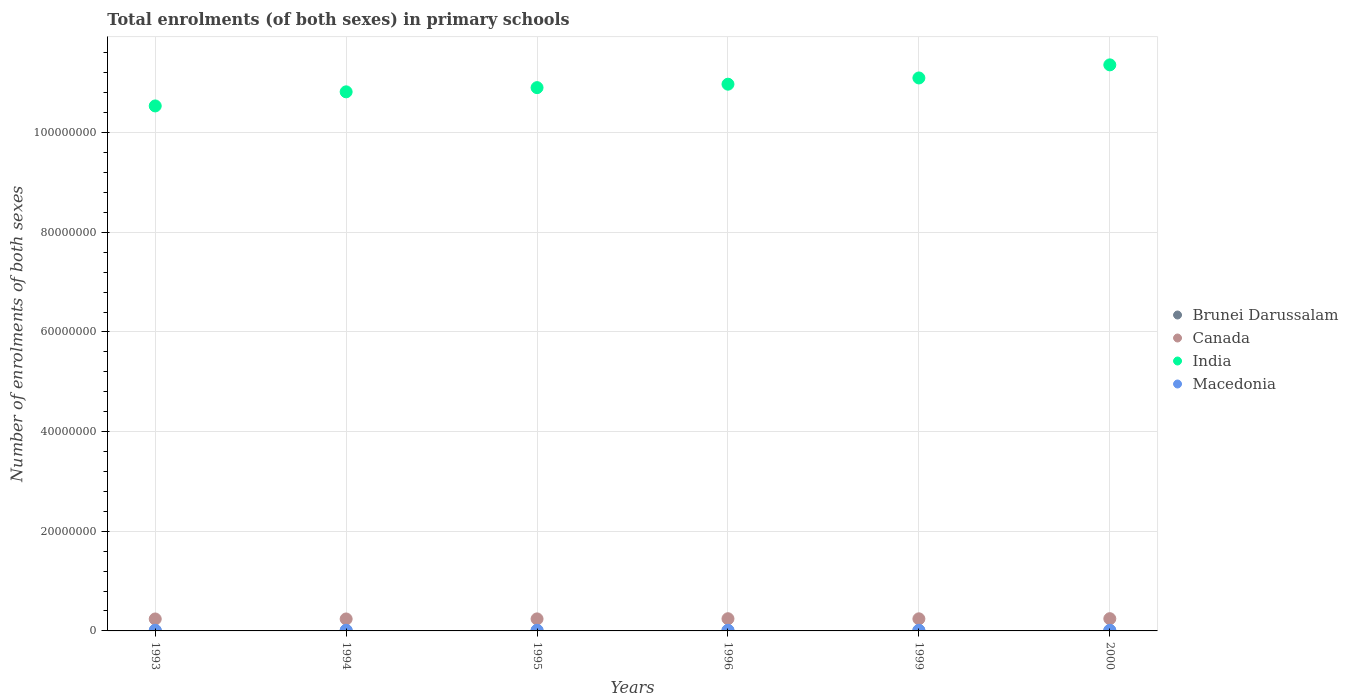How many different coloured dotlines are there?
Make the answer very short. 4. Is the number of dotlines equal to the number of legend labels?
Keep it short and to the point. Yes. What is the number of enrolments in primary schools in Macedonia in 1993?
Keep it short and to the point. 1.34e+05. Across all years, what is the maximum number of enrolments in primary schools in India?
Provide a succinct answer. 1.14e+08. Across all years, what is the minimum number of enrolments in primary schools in Canada?
Provide a succinct answer. 2.40e+06. In which year was the number of enrolments in primary schools in India maximum?
Provide a short and direct response. 2000. What is the total number of enrolments in primary schools in Canada in the graph?
Offer a terse response. 1.45e+07. What is the difference between the number of enrolments in primary schools in India in 1995 and that in 2000?
Provide a succinct answer. -4.57e+06. What is the difference between the number of enrolments in primary schools in Canada in 1999 and the number of enrolments in primary schools in Macedonia in 2000?
Offer a very short reply. 2.30e+06. What is the average number of enrolments in primary schools in Canada per year?
Your response must be concise. 2.42e+06. In the year 1995, what is the difference between the number of enrolments in primary schools in India and number of enrolments in primary schools in Brunei Darussalam?
Make the answer very short. 1.09e+08. In how many years, is the number of enrolments in primary schools in Brunei Darussalam greater than 12000000?
Your response must be concise. 0. What is the ratio of the number of enrolments in primary schools in Brunei Darussalam in 1995 to that in 2000?
Provide a succinct answer. 0.94. Is the difference between the number of enrolments in primary schools in India in 1994 and 2000 greater than the difference between the number of enrolments in primary schools in Brunei Darussalam in 1994 and 2000?
Make the answer very short. No. What is the difference between the highest and the second highest number of enrolments in primary schools in India?
Offer a terse response. 2.63e+06. What is the difference between the highest and the lowest number of enrolments in primary schools in Macedonia?
Keep it short and to the point. 7991. In how many years, is the number of enrolments in primary schools in Brunei Darussalam greater than the average number of enrolments in primary schools in Brunei Darussalam taken over all years?
Offer a very short reply. 2. Is the sum of the number of enrolments in primary schools in Canada in 1993 and 1996 greater than the maximum number of enrolments in primary schools in India across all years?
Your answer should be very brief. No. Is it the case that in every year, the sum of the number of enrolments in primary schools in India and number of enrolments in primary schools in Macedonia  is greater than the sum of number of enrolments in primary schools in Brunei Darussalam and number of enrolments in primary schools in Canada?
Provide a succinct answer. Yes. Is the number of enrolments in primary schools in India strictly greater than the number of enrolments in primary schools in Canada over the years?
Your response must be concise. Yes. Is the number of enrolments in primary schools in Brunei Darussalam strictly less than the number of enrolments in primary schools in Macedonia over the years?
Make the answer very short. Yes. How many dotlines are there?
Ensure brevity in your answer.  4. How many years are there in the graph?
Make the answer very short. 6. What is the difference between two consecutive major ticks on the Y-axis?
Provide a short and direct response. 2.00e+07. Are the values on the major ticks of Y-axis written in scientific E-notation?
Your answer should be compact. No. Does the graph contain any zero values?
Provide a succinct answer. No. How many legend labels are there?
Give a very brief answer. 4. What is the title of the graph?
Your response must be concise. Total enrolments (of both sexes) in primary schools. What is the label or title of the Y-axis?
Offer a terse response. Number of enrolments of both sexes. What is the Number of enrolments of both sexes of Brunei Darussalam in 1993?
Your answer should be compact. 4.11e+04. What is the Number of enrolments of both sexes in Canada in 1993?
Offer a terse response. 2.40e+06. What is the Number of enrolments of both sexes in India in 1993?
Your response must be concise. 1.05e+08. What is the Number of enrolments of both sexes in Macedonia in 1993?
Your response must be concise. 1.34e+05. What is the Number of enrolments of both sexes in Brunei Darussalam in 1994?
Offer a terse response. 4.23e+04. What is the Number of enrolments of both sexes in Canada in 1994?
Offer a very short reply. 2.40e+06. What is the Number of enrolments of both sexes of India in 1994?
Provide a short and direct response. 1.08e+08. What is the Number of enrolments of both sexes in Macedonia in 1994?
Provide a succinct answer. 1.34e+05. What is the Number of enrolments of both sexes of Brunei Darussalam in 1995?
Your answer should be very brief. 4.27e+04. What is the Number of enrolments of both sexes in Canada in 1995?
Your answer should be very brief. 2.41e+06. What is the Number of enrolments of both sexes in India in 1995?
Your answer should be compact. 1.09e+08. What is the Number of enrolments of both sexes in Macedonia in 1995?
Your answer should be compact. 1.34e+05. What is the Number of enrolments of both sexes in Brunei Darussalam in 1996?
Give a very brief answer. 4.33e+04. What is the Number of enrolments of both sexes in Canada in 1996?
Your answer should be very brief. 2.45e+06. What is the Number of enrolments of both sexes of India in 1996?
Ensure brevity in your answer.  1.10e+08. What is the Number of enrolments of both sexes in Macedonia in 1996?
Offer a very short reply. 1.35e+05. What is the Number of enrolments of both sexes of Brunei Darussalam in 1999?
Your answer should be very brief. 4.58e+04. What is the Number of enrolments of both sexes of Canada in 1999?
Your answer should be very brief. 2.43e+06. What is the Number of enrolments of both sexes in India in 1999?
Give a very brief answer. 1.11e+08. What is the Number of enrolments of both sexes of Macedonia in 1999?
Keep it short and to the point. 1.30e+05. What is the Number of enrolments of both sexes of Brunei Darussalam in 2000?
Your answer should be very brief. 4.54e+04. What is the Number of enrolments of both sexes of Canada in 2000?
Offer a very short reply. 2.46e+06. What is the Number of enrolments of both sexes in India in 2000?
Ensure brevity in your answer.  1.14e+08. What is the Number of enrolments of both sexes of Macedonia in 2000?
Provide a succinct answer. 1.27e+05. Across all years, what is the maximum Number of enrolments of both sexes in Brunei Darussalam?
Provide a succinct answer. 4.58e+04. Across all years, what is the maximum Number of enrolments of both sexes in Canada?
Provide a succinct answer. 2.46e+06. Across all years, what is the maximum Number of enrolments of both sexes of India?
Offer a terse response. 1.14e+08. Across all years, what is the maximum Number of enrolments of both sexes in Macedonia?
Keep it short and to the point. 1.35e+05. Across all years, what is the minimum Number of enrolments of both sexes of Brunei Darussalam?
Your response must be concise. 4.11e+04. Across all years, what is the minimum Number of enrolments of both sexes in Canada?
Your answer should be very brief. 2.40e+06. Across all years, what is the minimum Number of enrolments of both sexes of India?
Ensure brevity in your answer.  1.05e+08. Across all years, what is the minimum Number of enrolments of both sexes of Macedonia?
Offer a terse response. 1.27e+05. What is the total Number of enrolments of both sexes in Brunei Darussalam in the graph?
Provide a succinct answer. 2.61e+05. What is the total Number of enrolments of both sexes in Canada in the graph?
Offer a terse response. 1.45e+07. What is the total Number of enrolments of both sexes in India in the graph?
Your response must be concise. 6.57e+08. What is the total Number of enrolments of both sexes in Macedonia in the graph?
Provide a short and direct response. 7.93e+05. What is the difference between the Number of enrolments of both sexes of Brunei Darussalam in 1993 and that in 1994?
Keep it short and to the point. -1136. What is the difference between the Number of enrolments of both sexes of Canada in 1993 and that in 1994?
Ensure brevity in your answer.  -1595. What is the difference between the Number of enrolments of both sexes of India in 1993 and that in 1994?
Provide a succinct answer. -2.83e+06. What is the difference between the Number of enrolments of both sexes of Macedonia in 1993 and that in 1994?
Offer a very short reply. 516. What is the difference between the Number of enrolments of both sexes of Brunei Darussalam in 1993 and that in 1995?
Your answer should be very brief. -1538. What is the difference between the Number of enrolments of both sexes of Canada in 1993 and that in 1995?
Your response must be concise. -1.39e+04. What is the difference between the Number of enrolments of both sexes in India in 1993 and that in 1995?
Keep it short and to the point. -3.67e+06. What is the difference between the Number of enrolments of both sexes of Macedonia in 1993 and that in 1995?
Provide a succinct answer. 553. What is the difference between the Number of enrolments of both sexes in Brunei Darussalam in 1993 and that in 1996?
Ensure brevity in your answer.  -2157. What is the difference between the Number of enrolments of both sexes in Canada in 1993 and that in 1996?
Your answer should be very brief. -4.89e+04. What is the difference between the Number of enrolments of both sexes in India in 1993 and that in 1996?
Offer a very short reply. -4.36e+06. What is the difference between the Number of enrolments of both sexes in Macedonia in 1993 and that in 1996?
Your answer should be very brief. -337. What is the difference between the Number of enrolments of both sexes of Brunei Darussalam in 1993 and that in 1999?
Your answer should be very brief. -4693. What is the difference between the Number of enrolments of both sexes in Canada in 1993 and that in 1999?
Provide a short and direct response. -2.94e+04. What is the difference between the Number of enrolments of both sexes in India in 1993 and that in 1999?
Your answer should be very brief. -5.62e+06. What is the difference between the Number of enrolments of both sexes in Macedonia in 1993 and that in 1999?
Offer a very short reply. 4627. What is the difference between the Number of enrolments of both sexes in Brunei Darussalam in 1993 and that in 2000?
Keep it short and to the point. -4294. What is the difference between the Number of enrolments of both sexes in Canada in 1993 and that in 2000?
Your answer should be compact. -5.72e+04. What is the difference between the Number of enrolments of both sexes of India in 1993 and that in 2000?
Ensure brevity in your answer.  -8.24e+06. What is the difference between the Number of enrolments of both sexes of Macedonia in 1993 and that in 2000?
Offer a very short reply. 7654. What is the difference between the Number of enrolments of both sexes of Brunei Darussalam in 1994 and that in 1995?
Your answer should be very brief. -402. What is the difference between the Number of enrolments of both sexes in Canada in 1994 and that in 1995?
Keep it short and to the point. -1.23e+04. What is the difference between the Number of enrolments of both sexes in India in 1994 and that in 1995?
Provide a succinct answer. -8.43e+05. What is the difference between the Number of enrolments of both sexes in Brunei Darussalam in 1994 and that in 1996?
Your answer should be compact. -1021. What is the difference between the Number of enrolments of both sexes of Canada in 1994 and that in 1996?
Provide a succinct answer. -4.73e+04. What is the difference between the Number of enrolments of both sexes in India in 1994 and that in 1996?
Give a very brief answer. -1.53e+06. What is the difference between the Number of enrolments of both sexes in Macedonia in 1994 and that in 1996?
Provide a short and direct response. -853. What is the difference between the Number of enrolments of both sexes of Brunei Darussalam in 1994 and that in 1999?
Make the answer very short. -3557. What is the difference between the Number of enrolments of both sexes of Canada in 1994 and that in 1999?
Give a very brief answer. -2.78e+04. What is the difference between the Number of enrolments of both sexes of India in 1994 and that in 1999?
Offer a very short reply. -2.79e+06. What is the difference between the Number of enrolments of both sexes of Macedonia in 1994 and that in 1999?
Make the answer very short. 4111. What is the difference between the Number of enrolments of both sexes in Brunei Darussalam in 1994 and that in 2000?
Provide a short and direct response. -3158. What is the difference between the Number of enrolments of both sexes in Canada in 1994 and that in 2000?
Provide a short and direct response. -5.56e+04. What is the difference between the Number of enrolments of both sexes of India in 1994 and that in 2000?
Your response must be concise. -5.41e+06. What is the difference between the Number of enrolments of both sexes in Macedonia in 1994 and that in 2000?
Keep it short and to the point. 7138. What is the difference between the Number of enrolments of both sexes of Brunei Darussalam in 1995 and that in 1996?
Provide a succinct answer. -619. What is the difference between the Number of enrolments of both sexes in Canada in 1995 and that in 1996?
Provide a succinct answer. -3.50e+04. What is the difference between the Number of enrolments of both sexes in India in 1995 and that in 1996?
Offer a very short reply. -6.91e+05. What is the difference between the Number of enrolments of both sexes of Macedonia in 1995 and that in 1996?
Your answer should be very brief. -890. What is the difference between the Number of enrolments of both sexes in Brunei Darussalam in 1995 and that in 1999?
Your response must be concise. -3155. What is the difference between the Number of enrolments of both sexes in Canada in 1995 and that in 1999?
Give a very brief answer. -1.55e+04. What is the difference between the Number of enrolments of both sexes of India in 1995 and that in 1999?
Your answer should be very brief. -1.94e+06. What is the difference between the Number of enrolments of both sexes of Macedonia in 1995 and that in 1999?
Give a very brief answer. 4074. What is the difference between the Number of enrolments of both sexes in Brunei Darussalam in 1995 and that in 2000?
Give a very brief answer. -2756. What is the difference between the Number of enrolments of both sexes in Canada in 1995 and that in 2000?
Offer a terse response. -4.33e+04. What is the difference between the Number of enrolments of both sexes of India in 1995 and that in 2000?
Your response must be concise. -4.57e+06. What is the difference between the Number of enrolments of both sexes of Macedonia in 1995 and that in 2000?
Make the answer very short. 7101. What is the difference between the Number of enrolments of both sexes of Brunei Darussalam in 1996 and that in 1999?
Ensure brevity in your answer.  -2536. What is the difference between the Number of enrolments of both sexes of Canada in 1996 and that in 1999?
Your response must be concise. 1.95e+04. What is the difference between the Number of enrolments of both sexes of India in 1996 and that in 1999?
Provide a short and direct response. -1.25e+06. What is the difference between the Number of enrolments of both sexes in Macedonia in 1996 and that in 1999?
Your answer should be compact. 4964. What is the difference between the Number of enrolments of both sexes in Brunei Darussalam in 1996 and that in 2000?
Keep it short and to the point. -2137. What is the difference between the Number of enrolments of both sexes in Canada in 1996 and that in 2000?
Make the answer very short. -8290. What is the difference between the Number of enrolments of both sexes of India in 1996 and that in 2000?
Your response must be concise. -3.88e+06. What is the difference between the Number of enrolments of both sexes of Macedonia in 1996 and that in 2000?
Make the answer very short. 7991. What is the difference between the Number of enrolments of both sexes of Brunei Darussalam in 1999 and that in 2000?
Offer a terse response. 399. What is the difference between the Number of enrolments of both sexes in Canada in 1999 and that in 2000?
Keep it short and to the point. -2.78e+04. What is the difference between the Number of enrolments of both sexes in India in 1999 and that in 2000?
Offer a very short reply. -2.63e+06. What is the difference between the Number of enrolments of both sexes in Macedonia in 1999 and that in 2000?
Provide a succinct answer. 3027. What is the difference between the Number of enrolments of both sexes of Brunei Darussalam in 1993 and the Number of enrolments of both sexes of Canada in 1994?
Offer a terse response. -2.36e+06. What is the difference between the Number of enrolments of both sexes of Brunei Darussalam in 1993 and the Number of enrolments of both sexes of India in 1994?
Offer a very short reply. -1.08e+08. What is the difference between the Number of enrolments of both sexes in Brunei Darussalam in 1993 and the Number of enrolments of both sexes in Macedonia in 1994?
Make the answer very short. -9.26e+04. What is the difference between the Number of enrolments of both sexes in Canada in 1993 and the Number of enrolments of both sexes in India in 1994?
Offer a terse response. -1.06e+08. What is the difference between the Number of enrolments of both sexes of Canada in 1993 and the Number of enrolments of both sexes of Macedonia in 1994?
Your answer should be very brief. 2.27e+06. What is the difference between the Number of enrolments of both sexes of India in 1993 and the Number of enrolments of both sexes of Macedonia in 1994?
Keep it short and to the point. 1.05e+08. What is the difference between the Number of enrolments of both sexes of Brunei Darussalam in 1993 and the Number of enrolments of both sexes of Canada in 1995?
Give a very brief answer. -2.37e+06. What is the difference between the Number of enrolments of both sexes in Brunei Darussalam in 1993 and the Number of enrolments of both sexes in India in 1995?
Offer a terse response. -1.09e+08. What is the difference between the Number of enrolments of both sexes in Brunei Darussalam in 1993 and the Number of enrolments of both sexes in Macedonia in 1995?
Give a very brief answer. -9.26e+04. What is the difference between the Number of enrolments of both sexes in Canada in 1993 and the Number of enrolments of both sexes in India in 1995?
Your answer should be very brief. -1.07e+08. What is the difference between the Number of enrolments of both sexes in Canada in 1993 and the Number of enrolments of both sexes in Macedonia in 1995?
Offer a terse response. 2.27e+06. What is the difference between the Number of enrolments of both sexes in India in 1993 and the Number of enrolments of both sexes in Macedonia in 1995?
Your answer should be compact. 1.05e+08. What is the difference between the Number of enrolments of both sexes in Brunei Darussalam in 1993 and the Number of enrolments of both sexes in Canada in 1996?
Offer a very short reply. -2.41e+06. What is the difference between the Number of enrolments of both sexes of Brunei Darussalam in 1993 and the Number of enrolments of both sexes of India in 1996?
Ensure brevity in your answer.  -1.10e+08. What is the difference between the Number of enrolments of both sexes in Brunei Darussalam in 1993 and the Number of enrolments of both sexes in Macedonia in 1996?
Provide a succinct answer. -9.35e+04. What is the difference between the Number of enrolments of both sexes in Canada in 1993 and the Number of enrolments of both sexes in India in 1996?
Ensure brevity in your answer.  -1.07e+08. What is the difference between the Number of enrolments of both sexes of Canada in 1993 and the Number of enrolments of both sexes of Macedonia in 1996?
Offer a very short reply. 2.26e+06. What is the difference between the Number of enrolments of both sexes of India in 1993 and the Number of enrolments of both sexes of Macedonia in 1996?
Offer a very short reply. 1.05e+08. What is the difference between the Number of enrolments of both sexes of Brunei Darussalam in 1993 and the Number of enrolments of both sexes of Canada in 1999?
Your answer should be very brief. -2.39e+06. What is the difference between the Number of enrolments of both sexes in Brunei Darussalam in 1993 and the Number of enrolments of both sexes in India in 1999?
Your answer should be compact. -1.11e+08. What is the difference between the Number of enrolments of both sexes of Brunei Darussalam in 1993 and the Number of enrolments of both sexes of Macedonia in 1999?
Provide a succinct answer. -8.85e+04. What is the difference between the Number of enrolments of both sexes of Canada in 1993 and the Number of enrolments of both sexes of India in 1999?
Your response must be concise. -1.09e+08. What is the difference between the Number of enrolments of both sexes in Canada in 1993 and the Number of enrolments of both sexes in Macedonia in 1999?
Your answer should be very brief. 2.27e+06. What is the difference between the Number of enrolments of both sexes of India in 1993 and the Number of enrolments of both sexes of Macedonia in 1999?
Provide a short and direct response. 1.05e+08. What is the difference between the Number of enrolments of both sexes of Brunei Darussalam in 1993 and the Number of enrolments of both sexes of Canada in 2000?
Your response must be concise. -2.42e+06. What is the difference between the Number of enrolments of both sexes in Brunei Darussalam in 1993 and the Number of enrolments of both sexes in India in 2000?
Offer a terse response. -1.14e+08. What is the difference between the Number of enrolments of both sexes in Brunei Darussalam in 1993 and the Number of enrolments of both sexes in Macedonia in 2000?
Provide a succinct answer. -8.55e+04. What is the difference between the Number of enrolments of both sexes of Canada in 1993 and the Number of enrolments of both sexes of India in 2000?
Give a very brief answer. -1.11e+08. What is the difference between the Number of enrolments of both sexes in Canada in 1993 and the Number of enrolments of both sexes in Macedonia in 2000?
Offer a terse response. 2.27e+06. What is the difference between the Number of enrolments of both sexes in India in 1993 and the Number of enrolments of both sexes in Macedonia in 2000?
Your answer should be very brief. 1.05e+08. What is the difference between the Number of enrolments of both sexes of Brunei Darussalam in 1994 and the Number of enrolments of both sexes of Canada in 1995?
Your response must be concise. -2.37e+06. What is the difference between the Number of enrolments of both sexes in Brunei Darussalam in 1994 and the Number of enrolments of both sexes in India in 1995?
Ensure brevity in your answer.  -1.09e+08. What is the difference between the Number of enrolments of both sexes in Brunei Darussalam in 1994 and the Number of enrolments of both sexes in Macedonia in 1995?
Keep it short and to the point. -9.14e+04. What is the difference between the Number of enrolments of both sexes of Canada in 1994 and the Number of enrolments of both sexes of India in 1995?
Make the answer very short. -1.07e+08. What is the difference between the Number of enrolments of both sexes in Canada in 1994 and the Number of enrolments of both sexes in Macedonia in 1995?
Keep it short and to the point. 2.27e+06. What is the difference between the Number of enrolments of both sexes in India in 1994 and the Number of enrolments of both sexes in Macedonia in 1995?
Offer a terse response. 1.08e+08. What is the difference between the Number of enrolments of both sexes in Brunei Darussalam in 1994 and the Number of enrolments of both sexes in Canada in 1996?
Your answer should be compact. -2.41e+06. What is the difference between the Number of enrolments of both sexes of Brunei Darussalam in 1994 and the Number of enrolments of both sexes of India in 1996?
Provide a short and direct response. -1.10e+08. What is the difference between the Number of enrolments of both sexes in Brunei Darussalam in 1994 and the Number of enrolments of both sexes in Macedonia in 1996?
Your answer should be compact. -9.23e+04. What is the difference between the Number of enrolments of both sexes of Canada in 1994 and the Number of enrolments of both sexes of India in 1996?
Provide a short and direct response. -1.07e+08. What is the difference between the Number of enrolments of both sexes of Canada in 1994 and the Number of enrolments of both sexes of Macedonia in 1996?
Offer a terse response. 2.27e+06. What is the difference between the Number of enrolments of both sexes of India in 1994 and the Number of enrolments of both sexes of Macedonia in 1996?
Your answer should be very brief. 1.08e+08. What is the difference between the Number of enrolments of both sexes of Brunei Darussalam in 1994 and the Number of enrolments of both sexes of Canada in 1999?
Make the answer very short. -2.39e+06. What is the difference between the Number of enrolments of both sexes of Brunei Darussalam in 1994 and the Number of enrolments of both sexes of India in 1999?
Your answer should be very brief. -1.11e+08. What is the difference between the Number of enrolments of both sexes in Brunei Darussalam in 1994 and the Number of enrolments of both sexes in Macedonia in 1999?
Give a very brief answer. -8.74e+04. What is the difference between the Number of enrolments of both sexes of Canada in 1994 and the Number of enrolments of both sexes of India in 1999?
Your answer should be very brief. -1.09e+08. What is the difference between the Number of enrolments of both sexes in Canada in 1994 and the Number of enrolments of both sexes in Macedonia in 1999?
Offer a very short reply. 2.27e+06. What is the difference between the Number of enrolments of both sexes of India in 1994 and the Number of enrolments of both sexes of Macedonia in 1999?
Your response must be concise. 1.08e+08. What is the difference between the Number of enrolments of both sexes of Brunei Darussalam in 1994 and the Number of enrolments of both sexes of Canada in 2000?
Offer a very short reply. -2.41e+06. What is the difference between the Number of enrolments of both sexes of Brunei Darussalam in 1994 and the Number of enrolments of both sexes of India in 2000?
Provide a succinct answer. -1.14e+08. What is the difference between the Number of enrolments of both sexes in Brunei Darussalam in 1994 and the Number of enrolments of both sexes in Macedonia in 2000?
Give a very brief answer. -8.43e+04. What is the difference between the Number of enrolments of both sexes of Canada in 1994 and the Number of enrolments of both sexes of India in 2000?
Keep it short and to the point. -1.11e+08. What is the difference between the Number of enrolments of both sexes of Canada in 1994 and the Number of enrolments of both sexes of Macedonia in 2000?
Offer a very short reply. 2.27e+06. What is the difference between the Number of enrolments of both sexes of India in 1994 and the Number of enrolments of both sexes of Macedonia in 2000?
Offer a terse response. 1.08e+08. What is the difference between the Number of enrolments of both sexes in Brunei Darussalam in 1995 and the Number of enrolments of both sexes in Canada in 1996?
Your answer should be very brief. -2.41e+06. What is the difference between the Number of enrolments of both sexes in Brunei Darussalam in 1995 and the Number of enrolments of both sexes in India in 1996?
Offer a terse response. -1.10e+08. What is the difference between the Number of enrolments of both sexes in Brunei Darussalam in 1995 and the Number of enrolments of both sexes in Macedonia in 1996?
Give a very brief answer. -9.19e+04. What is the difference between the Number of enrolments of both sexes in Canada in 1995 and the Number of enrolments of both sexes in India in 1996?
Your response must be concise. -1.07e+08. What is the difference between the Number of enrolments of both sexes of Canada in 1995 and the Number of enrolments of both sexes of Macedonia in 1996?
Make the answer very short. 2.28e+06. What is the difference between the Number of enrolments of both sexes in India in 1995 and the Number of enrolments of both sexes in Macedonia in 1996?
Your answer should be very brief. 1.09e+08. What is the difference between the Number of enrolments of both sexes of Brunei Darussalam in 1995 and the Number of enrolments of both sexes of Canada in 1999?
Your answer should be compact. -2.39e+06. What is the difference between the Number of enrolments of both sexes of Brunei Darussalam in 1995 and the Number of enrolments of both sexes of India in 1999?
Offer a very short reply. -1.11e+08. What is the difference between the Number of enrolments of both sexes in Brunei Darussalam in 1995 and the Number of enrolments of both sexes in Macedonia in 1999?
Make the answer very short. -8.70e+04. What is the difference between the Number of enrolments of both sexes of Canada in 1995 and the Number of enrolments of both sexes of India in 1999?
Provide a succinct answer. -1.09e+08. What is the difference between the Number of enrolments of both sexes of Canada in 1995 and the Number of enrolments of both sexes of Macedonia in 1999?
Offer a terse response. 2.28e+06. What is the difference between the Number of enrolments of both sexes of India in 1995 and the Number of enrolments of both sexes of Macedonia in 1999?
Provide a short and direct response. 1.09e+08. What is the difference between the Number of enrolments of both sexes in Brunei Darussalam in 1995 and the Number of enrolments of both sexes in Canada in 2000?
Ensure brevity in your answer.  -2.41e+06. What is the difference between the Number of enrolments of both sexes in Brunei Darussalam in 1995 and the Number of enrolments of both sexes in India in 2000?
Your answer should be very brief. -1.14e+08. What is the difference between the Number of enrolments of both sexes of Brunei Darussalam in 1995 and the Number of enrolments of both sexes of Macedonia in 2000?
Provide a succinct answer. -8.39e+04. What is the difference between the Number of enrolments of both sexes in Canada in 1995 and the Number of enrolments of both sexes in India in 2000?
Ensure brevity in your answer.  -1.11e+08. What is the difference between the Number of enrolments of both sexes of Canada in 1995 and the Number of enrolments of both sexes of Macedonia in 2000?
Provide a succinct answer. 2.29e+06. What is the difference between the Number of enrolments of both sexes in India in 1995 and the Number of enrolments of both sexes in Macedonia in 2000?
Your answer should be compact. 1.09e+08. What is the difference between the Number of enrolments of both sexes in Brunei Darussalam in 1996 and the Number of enrolments of both sexes in Canada in 1999?
Keep it short and to the point. -2.39e+06. What is the difference between the Number of enrolments of both sexes of Brunei Darussalam in 1996 and the Number of enrolments of both sexes of India in 1999?
Keep it short and to the point. -1.11e+08. What is the difference between the Number of enrolments of both sexes in Brunei Darussalam in 1996 and the Number of enrolments of both sexes in Macedonia in 1999?
Give a very brief answer. -8.63e+04. What is the difference between the Number of enrolments of both sexes in Canada in 1996 and the Number of enrolments of both sexes in India in 1999?
Your answer should be compact. -1.09e+08. What is the difference between the Number of enrolments of both sexes in Canada in 1996 and the Number of enrolments of both sexes in Macedonia in 1999?
Make the answer very short. 2.32e+06. What is the difference between the Number of enrolments of both sexes in India in 1996 and the Number of enrolments of both sexes in Macedonia in 1999?
Ensure brevity in your answer.  1.10e+08. What is the difference between the Number of enrolments of both sexes of Brunei Darussalam in 1996 and the Number of enrolments of both sexes of Canada in 2000?
Offer a terse response. -2.41e+06. What is the difference between the Number of enrolments of both sexes of Brunei Darussalam in 1996 and the Number of enrolments of both sexes of India in 2000?
Provide a short and direct response. -1.14e+08. What is the difference between the Number of enrolments of both sexes of Brunei Darussalam in 1996 and the Number of enrolments of both sexes of Macedonia in 2000?
Ensure brevity in your answer.  -8.33e+04. What is the difference between the Number of enrolments of both sexes of Canada in 1996 and the Number of enrolments of both sexes of India in 2000?
Your answer should be compact. -1.11e+08. What is the difference between the Number of enrolments of both sexes of Canada in 1996 and the Number of enrolments of both sexes of Macedonia in 2000?
Your response must be concise. 2.32e+06. What is the difference between the Number of enrolments of both sexes in India in 1996 and the Number of enrolments of both sexes in Macedonia in 2000?
Ensure brevity in your answer.  1.10e+08. What is the difference between the Number of enrolments of both sexes in Brunei Darussalam in 1999 and the Number of enrolments of both sexes in Canada in 2000?
Offer a terse response. -2.41e+06. What is the difference between the Number of enrolments of both sexes of Brunei Darussalam in 1999 and the Number of enrolments of both sexes of India in 2000?
Your answer should be compact. -1.14e+08. What is the difference between the Number of enrolments of both sexes of Brunei Darussalam in 1999 and the Number of enrolments of both sexes of Macedonia in 2000?
Offer a very short reply. -8.08e+04. What is the difference between the Number of enrolments of both sexes of Canada in 1999 and the Number of enrolments of both sexes of India in 2000?
Keep it short and to the point. -1.11e+08. What is the difference between the Number of enrolments of both sexes of Canada in 1999 and the Number of enrolments of both sexes of Macedonia in 2000?
Keep it short and to the point. 2.30e+06. What is the difference between the Number of enrolments of both sexes in India in 1999 and the Number of enrolments of both sexes in Macedonia in 2000?
Offer a very short reply. 1.11e+08. What is the average Number of enrolments of both sexes of Brunei Darussalam per year?
Make the answer very short. 4.34e+04. What is the average Number of enrolments of both sexes of Canada per year?
Give a very brief answer. 2.42e+06. What is the average Number of enrolments of both sexes in India per year?
Provide a succinct answer. 1.09e+08. What is the average Number of enrolments of both sexes in Macedonia per year?
Your answer should be compact. 1.32e+05. In the year 1993, what is the difference between the Number of enrolments of both sexes in Brunei Darussalam and Number of enrolments of both sexes in Canada?
Your answer should be compact. -2.36e+06. In the year 1993, what is the difference between the Number of enrolments of both sexes of Brunei Darussalam and Number of enrolments of both sexes of India?
Offer a terse response. -1.05e+08. In the year 1993, what is the difference between the Number of enrolments of both sexes of Brunei Darussalam and Number of enrolments of both sexes of Macedonia?
Provide a short and direct response. -9.31e+04. In the year 1993, what is the difference between the Number of enrolments of both sexes of Canada and Number of enrolments of both sexes of India?
Your answer should be compact. -1.03e+08. In the year 1993, what is the difference between the Number of enrolments of both sexes in Canada and Number of enrolments of both sexes in Macedonia?
Make the answer very short. 2.26e+06. In the year 1993, what is the difference between the Number of enrolments of both sexes in India and Number of enrolments of both sexes in Macedonia?
Keep it short and to the point. 1.05e+08. In the year 1994, what is the difference between the Number of enrolments of both sexes of Brunei Darussalam and Number of enrolments of both sexes of Canada?
Your answer should be very brief. -2.36e+06. In the year 1994, what is the difference between the Number of enrolments of both sexes in Brunei Darussalam and Number of enrolments of both sexes in India?
Offer a terse response. -1.08e+08. In the year 1994, what is the difference between the Number of enrolments of both sexes of Brunei Darussalam and Number of enrolments of both sexes of Macedonia?
Keep it short and to the point. -9.15e+04. In the year 1994, what is the difference between the Number of enrolments of both sexes in Canada and Number of enrolments of both sexes in India?
Your answer should be compact. -1.06e+08. In the year 1994, what is the difference between the Number of enrolments of both sexes in Canada and Number of enrolments of both sexes in Macedonia?
Provide a succinct answer. 2.27e+06. In the year 1994, what is the difference between the Number of enrolments of both sexes of India and Number of enrolments of both sexes of Macedonia?
Offer a very short reply. 1.08e+08. In the year 1995, what is the difference between the Number of enrolments of both sexes of Brunei Darussalam and Number of enrolments of both sexes of Canada?
Give a very brief answer. -2.37e+06. In the year 1995, what is the difference between the Number of enrolments of both sexes of Brunei Darussalam and Number of enrolments of both sexes of India?
Provide a short and direct response. -1.09e+08. In the year 1995, what is the difference between the Number of enrolments of both sexes in Brunei Darussalam and Number of enrolments of both sexes in Macedonia?
Ensure brevity in your answer.  -9.10e+04. In the year 1995, what is the difference between the Number of enrolments of both sexes of Canada and Number of enrolments of both sexes of India?
Provide a succinct answer. -1.07e+08. In the year 1995, what is the difference between the Number of enrolments of both sexes in Canada and Number of enrolments of both sexes in Macedonia?
Keep it short and to the point. 2.28e+06. In the year 1995, what is the difference between the Number of enrolments of both sexes of India and Number of enrolments of both sexes of Macedonia?
Provide a short and direct response. 1.09e+08. In the year 1996, what is the difference between the Number of enrolments of both sexes of Brunei Darussalam and Number of enrolments of both sexes of Canada?
Give a very brief answer. -2.40e+06. In the year 1996, what is the difference between the Number of enrolments of both sexes of Brunei Darussalam and Number of enrolments of both sexes of India?
Your answer should be compact. -1.10e+08. In the year 1996, what is the difference between the Number of enrolments of both sexes in Brunei Darussalam and Number of enrolments of both sexes in Macedonia?
Provide a short and direct response. -9.13e+04. In the year 1996, what is the difference between the Number of enrolments of both sexes in Canada and Number of enrolments of both sexes in India?
Your answer should be very brief. -1.07e+08. In the year 1996, what is the difference between the Number of enrolments of both sexes of Canada and Number of enrolments of both sexes of Macedonia?
Offer a very short reply. 2.31e+06. In the year 1996, what is the difference between the Number of enrolments of both sexes in India and Number of enrolments of both sexes in Macedonia?
Offer a terse response. 1.10e+08. In the year 1999, what is the difference between the Number of enrolments of both sexes of Brunei Darussalam and Number of enrolments of both sexes of Canada?
Provide a succinct answer. -2.38e+06. In the year 1999, what is the difference between the Number of enrolments of both sexes in Brunei Darussalam and Number of enrolments of both sexes in India?
Offer a very short reply. -1.11e+08. In the year 1999, what is the difference between the Number of enrolments of both sexes of Brunei Darussalam and Number of enrolments of both sexes of Macedonia?
Offer a very short reply. -8.38e+04. In the year 1999, what is the difference between the Number of enrolments of both sexes of Canada and Number of enrolments of both sexes of India?
Make the answer very short. -1.09e+08. In the year 1999, what is the difference between the Number of enrolments of both sexes of Canada and Number of enrolments of both sexes of Macedonia?
Your answer should be very brief. 2.30e+06. In the year 1999, what is the difference between the Number of enrolments of both sexes in India and Number of enrolments of both sexes in Macedonia?
Provide a succinct answer. 1.11e+08. In the year 2000, what is the difference between the Number of enrolments of both sexes of Brunei Darussalam and Number of enrolments of both sexes of Canada?
Your response must be concise. -2.41e+06. In the year 2000, what is the difference between the Number of enrolments of both sexes in Brunei Darussalam and Number of enrolments of both sexes in India?
Provide a short and direct response. -1.14e+08. In the year 2000, what is the difference between the Number of enrolments of both sexes of Brunei Darussalam and Number of enrolments of both sexes of Macedonia?
Your answer should be very brief. -8.12e+04. In the year 2000, what is the difference between the Number of enrolments of both sexes of Canada and Number of enrolments of both sexes of India?
Make the answer very short. -1.11e+08. In the year 2000, what is the difference between the Number of enrolments of both sexes of Canada and Number of enrolments of both sexes of Macedonia?
Give a very brief answer. 2.33e+06. In the year 2000, what is the difference between the Number of enrolments of both sexes of India and Number of enrolments of both sexes of Macedonia?
Give a very brief answer. 1.13e+08. What is the ratio of the Number of enrolments of both sexes of Brunei Darussalam in 1993 to that in 1994?
Your answer should be compact. 0.97. What is the ratio of the Number of enrolments of both sexes in India in 1993 to that in 1994?
Provide a short and direct response. 0.97. What is the ratio of the Number of enrolments of both sexes in Macedonia in 1993 to that in 1994?
Provide a short and direct response. 1. What is the ratio of the Number of enrolments of both sexes in Brunei Darussalam in 1993 to that in 1995?
Provide a short and direct response. 0.96. What is the ratio of the Number of enrolments of both sexes of Canada in 1993 to that in 1995?
Provide a succinct answer. 0.99. What is the ratio of the Number of enrolments of both sexes in India in 1993 to that in 1995?
Your response must be concise. 0.97. What is the ratio of the Number of enrolments of both sexes in Brunei Darussalam in 1993 to that in 1996?
Ensure brevity in your answer.  0.95. What is the ratio of the Number of enrolments of both sexes in Canada in 1993 to that in 1996?
Offer a terse response. 0.98. What is the ratio of the Number of enrolments of both sexes in India in 1993 to that in 1996?
Provide a short and direct response. 0.96. What is the ratio of the Number of enrolments of both sexes of Macedonia in 1993 to that in 1996?
Your answer should be compact. 1. What is the ratio of the Number of enrolments of both sexes of Brunei Darussalam in 1993 to that in 1999?
Offer a terse response. 0.9. What is the ratio of the Number of enrolments of both sexes in Canada in 1993 to that in 1999?
Make the answer very short. 0.99. What is the ratio of the Number of enrolments of both sexes of India in 1993 to that in 1999?
Your answer should be compact. 0.95. What is the ratio of the Number of enrolments of both sexes in Macedonia in 1993 to that in 1999?
Keep it short and to the point. 1.04. What is the ratio of the Number of enrolments of both sexes in Brunei Darussalam in 1993 to that in 2000?
Offer a terse response. 0.91. What is the ratio of the Number of enrolments of both sexes in Canada in 1993 to that in 2000?
Give a very brief answer. 0.98. What is the ratio of the Number of enrolments of both sexes of India in 1993 to that in 2000?
Keep it short and to the point. 0.93. What is the ratio of the Number of enrolments of both sexes of Macedonia in 1993 to that in 2000?
Your answer should be very brief. 1.06. What is the ratio of the Number of enrolments of both sexes in Brunei Darussalam in 1994 to that in 1995?
Offer a terse response. 0.99. What is the ratio of the Number of enrolments of both sexes of Canada in 1994 to that in 1995?
Offer a very short reply. 0.99. What is the ratio of the Number of enrolments of both sexes of India in 1994 to that in 1995?
Your response must be concise. 0.99. What is the ratio of the Number of enrolments of both sexes of Macedonia in 1994 to that in 1995?
Your answer should be very brief. 1. What is the ratio of the Number of enrolments of both sexes in Brunei Darussalam in 1994 to that in 1996?
Offer a very short reply. 0.98. What is the ratio of the Number of enrolments of both sexes of Canada in 1994 to that in 1996?
Your answer should be very brief. 0.98. What is the ratio of the Number of enrolments of both sexes in India in 1994 to that in 1996?
Your response must be concise. 0.99. What is the ratio of the Number of enrolments of both sexes in Brunei Darussalam in 1994 to that in 1999?
Give a very brief answer. 0.92. What is the ratio of the Number of enrolments of both sexes in India in 1994 to that in 1999?
Your answer should be compact. 0.97. What is the ratio of the Number of enrolments of both sexes in Macedonia in 1994 to that in 1999?
Your response must be concise. 1.03. What is the ratio of the Number of enrolments of both sexes of Brunei Darussalam in 1994 to that in 2000?
Your response must be concise. 0.93. What is the ratio of the Number of enrolments of both sexes in Canada in 1994 to that in 2000?
Your response must be concise. 0.98. What is the ratio of the Number of enrolments of both sexes of India in 1994 to that in 2000?
Give a very brief answer. 0.95. What is the ratio of the Number of enrolments of both sexes in Macedonia in 1994 to that in 2000?
Keep it short and to the point. 1.06. What is the ratio of the Number of enrolments of both sexes in Brunei Darussalam in 1995 to that in 1996?
Ensure brevity in your answer.  0.99. What is the ratio of the Number of enrolments of both sexes in Canada in 1995 to that in 1996?
Your response must be concise. 0.99. What is the ratio of the Number of enrolments of both sexes in India in 1995 to that in 1996?
Your response must be concise. 0.99. What is the ratio of the Number of enrolments of both sexes in Brunei Darussalam in 1995 to that in 1999?
Make the answer very short. 0.93. What is the ratio of the Number of enrolments of both sexes of Canada in 1995 to that in 1999?
Your response must be concise. 0.99. What is the ratio of the Number of enrolments of both sexes in India in 1995 to that in 1999?
Offer a very short reply. 0.98. What is the ratio of the Number of enrolments of both sexes in Macedonia in 1995 to that in 1999?
Give a very brief answer. 1.03. What is the ratio of the Number of enrolments of both sexes of Brunei Darussalam in 1995 to that in 2000?
Your answer should be very brief. 0.94. What is the ratio of the Number of enrolments of both sexes of Canada in 1995 to that in 2000?
Provide a succinct answer. 0.98. What is the ratio of the Number of enrolments of both sexes of India in 1995 to that in 2000?
Offer a terse response. 0.96. What is the ratio of the Number of enrolments of both sexes in Macedonia in 1995 to that in 2000?
Ensure brevity in your answer.  1.06. What is the ratio of the Number of enrolments of both sexes of Brunei Darussalam in 1996 to that in 1999?
Provide a succinct answer. 0.94. What is the ratio of the Number of enrolments of both sexes of India in 1996 to that in 1999?
Keep it short and to the point. 0.99. What is the ratio of the Number of enrolments of both sexes of Macedonia in 1996 to that in 1999?
Your answer should be compact. 1.04. What is the ratio of the Number of enrolments of both sexes of Brunei Darussalam in 1996 to that in 2000?
Your response must be concise. 0.95. What is the ratio of the Number of enrolments of both sexes of Canada in 1996 to that in 2000?
Offer a very short reply. 1. What is the ratio of the Number of enrolments of both sexes in India in 1996 to that in 2000?
Your answer should be very brief. 0.97. What is the ratio of the Number of enrolments of both sexes in Macedonia in 1996 to that in 2000?
Offer a very short reply. 1.06. What is the ratio of the Number of enrolments of both sexes of Brunei Darussalam in 1999 to that in 2000?
Keep it short and to the point. 1.01. What is the ratio of the Number of enrolments of both sexes in Canada in 1999 to that in 2000?
Provide a short and direct response. 0.99. What is the ratio of the Number of enrolments of both sexes in India in 1999 to that in 2000?
Offer a terse response. 0.98. What is the ratio of the Number of enrolments of both sexes of Macedonia in 1999 to that in 2000?
Ensure brevity in your answer.  1.02. What is the difference between the highest and the second highest Number of enrolments of both sexes in Brunei Darussalam?
Offer a terse response. 399. What is the difference between the highest and the second highest Number of enrolments of both sexes in Canada?
Offer a terse response. 8290. What is the difference between the highest and the second highest Number of enrolments of both sexes of India?
Your answer should be very brief. 2.63e+06. What is the difference between the highest and the second highest Number of enrolments of both sexes of Macedonia?
Offer a very short reply. 337. What is the difference between the highest and the lowest Number of enrolments of both sexes in Brunei Darussalam?
Provide a succinct answer. 4693. What is the difference between the highest and the lowest Number of enrolments of both sexes of Canada?
Your answer should be very brief. 5.72e+04. What is the difference between the highest and the lowest Number of enrolments of both sexes in India?
Keep it short and to the point. 8.24e+06. What is the difference between the highest and the lowest Number of enrolments of both sexes of Macedonia?
Provide a succinct answer. 7991. 